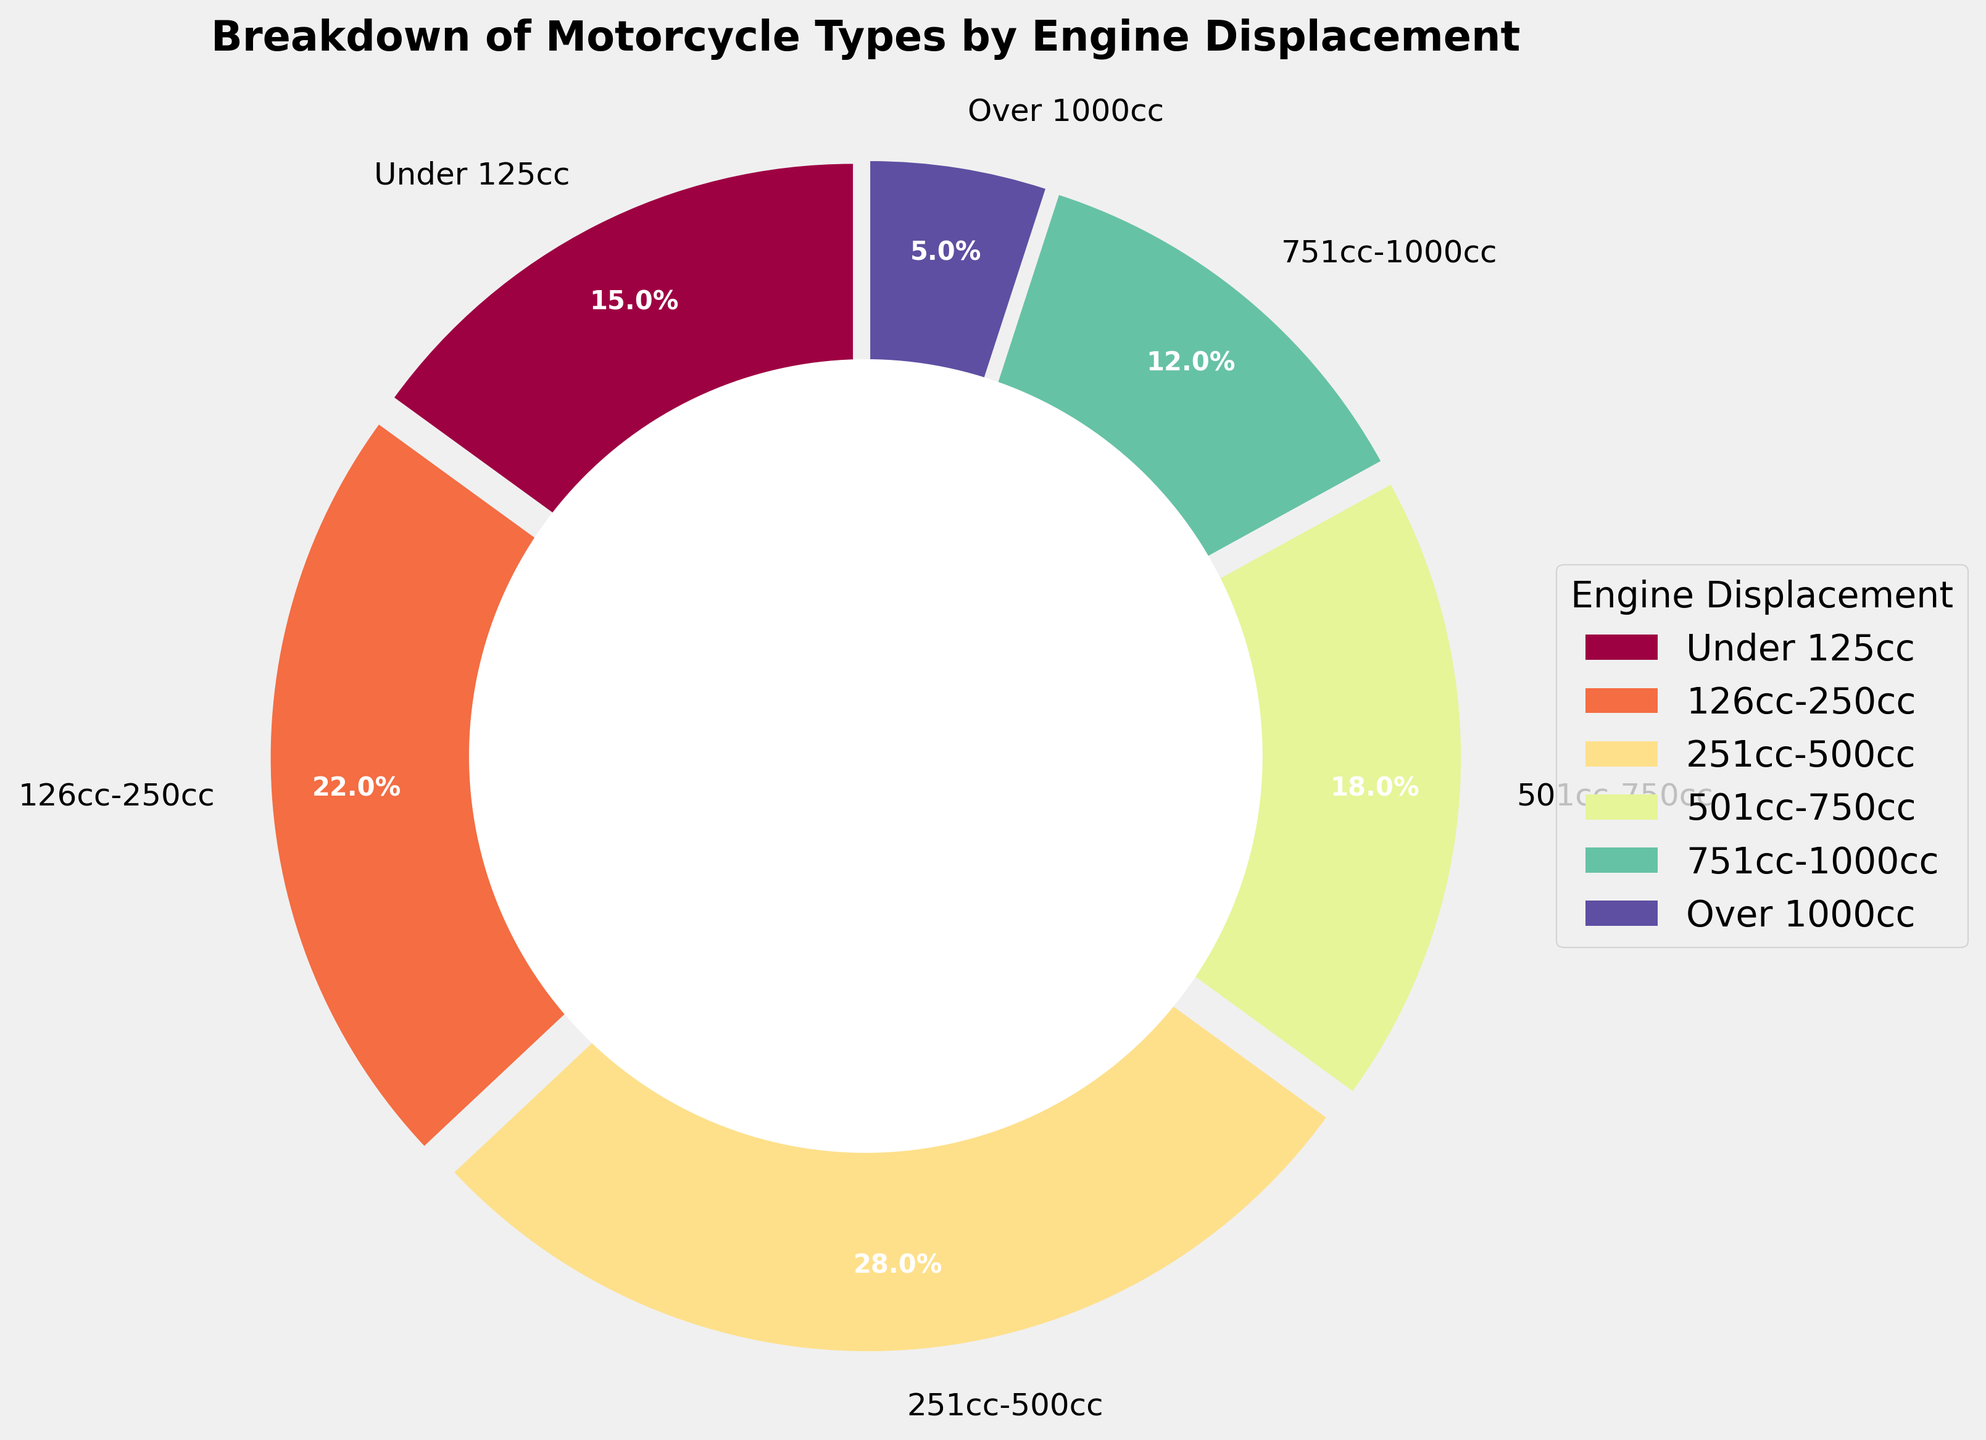What's the largest segment in terms of percentage? To find the largest segment by percentage, look at the labels and the corresponding percentages in the pie chart. Identify the segment with the highest percentage.
Answer: 251cc-500cc Which two engine displacement categories combined make up more than half of the motorcycles? Summing up the percentages from the chart: Under 125cc (15%) + 126cc-250cc (22%) + 251cc-500cc (28%) = 65%, so 126cc-250cc and 251cc-500cc combined make up more than half.
Answer: 126cc-250cc and 251cc-500cc Are there more motorcycles above 500cc or below 500cc? Sum the percentages for motorcycles above 500cc: 501cc-750cc (18%) + 751cc-1000cc (12%) + Over 1000cc (5%) = 35%. For below 500cc: Under 125cc (15%) + 126cc-250cc (22%) + 251cc-500cc (28%) = 65%.
Answer: Below 500cc What is the smallest segment in terms of percentage? Check the pie chart and find the segment with the smallest percentage.
Answer: Over 1000cc What is the combined percentage of motorcycles with engine displacement between 501cc and 1000cc? Add the percentages of the 501cc-750cc and 751cc-1000cc categories: 18% + 12% = 30%.
Answer: 30% Which segment is colored the lightest? Identify the segment with the lightest color in the pie chart, which visually maps to the smallest percentage.
Answer: Over 1000cc How much more percentage does the 251cc-500cc segment have than the 126cc-250cc segment? Subtract the percentage of the 126cc-250cc segment from the 251cc-500cc segment: 28% - 22% = 6%.
Answer: 6% Is the percentage of motorcycles in the 751cc-1000cc category greater than in the Under 125cc category? Compare the two percentages: 12% (751cc-1000cc) and 15% (Under 125cc). The percentage in the Under 125cc category is higher.
Answer: No How many segments are there in total? Count the total number of segments labeled in the pie chart.
Answer: 6 What percentage of motorcycles have an engine displacement of 500cc or less? Sum the percentages for the segments that are 500cc or less: Under 125cc (15%) + 126cc-250cc (22%) + 251cc-500cc (28%) = 65%.
Answer: 65% 